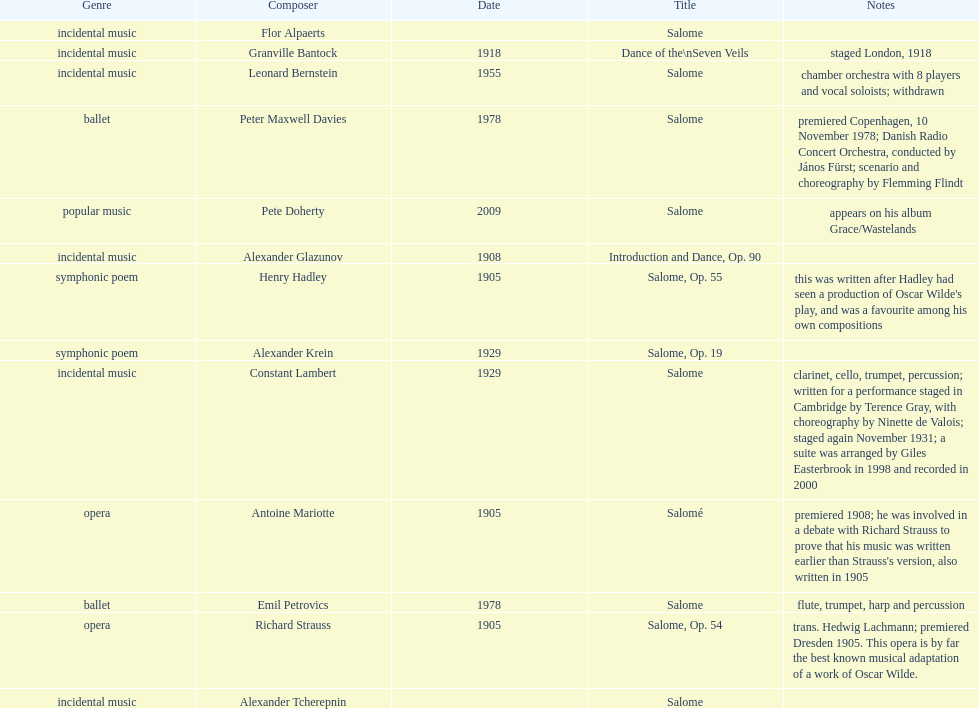Who is next on the list after alexander krein? Constant Lambert. 